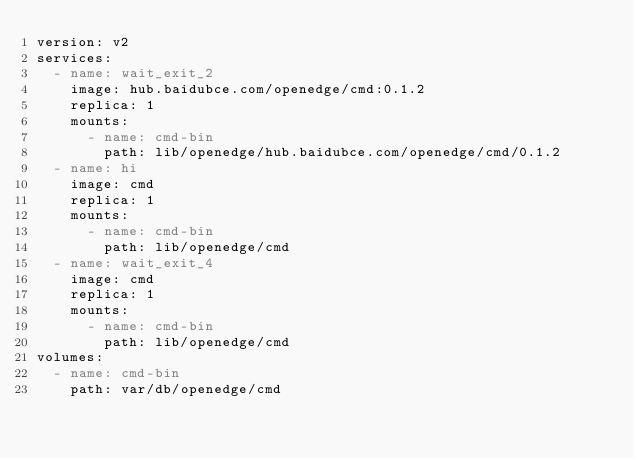<code> <loc_0><loc_0><loc_500><loc_500><_YAML_>version: v2
services:
  - name: wait_exit_2
    image: hub.baidubce.com/openedge/cmd:0.1.2
    replica: 1
    mounts:
      - name: cmd-bin
        path: lib/openedge/hub.baidubce.com/openedge/cmd/0.1.2
  - name: hi
    image: cmd
    replica: 1
    mounts:
      - name: cmd-bin
        path: lib/openedge/cmd
  - name: wait_exit_4
    image: cmd
    replica: 1
    mounts:
      - name: cmd-bin
        path: lib/openedge/cmd
volumes:
  - name: cmd-bin
    path: var/db/openedge/cmd
</code> 